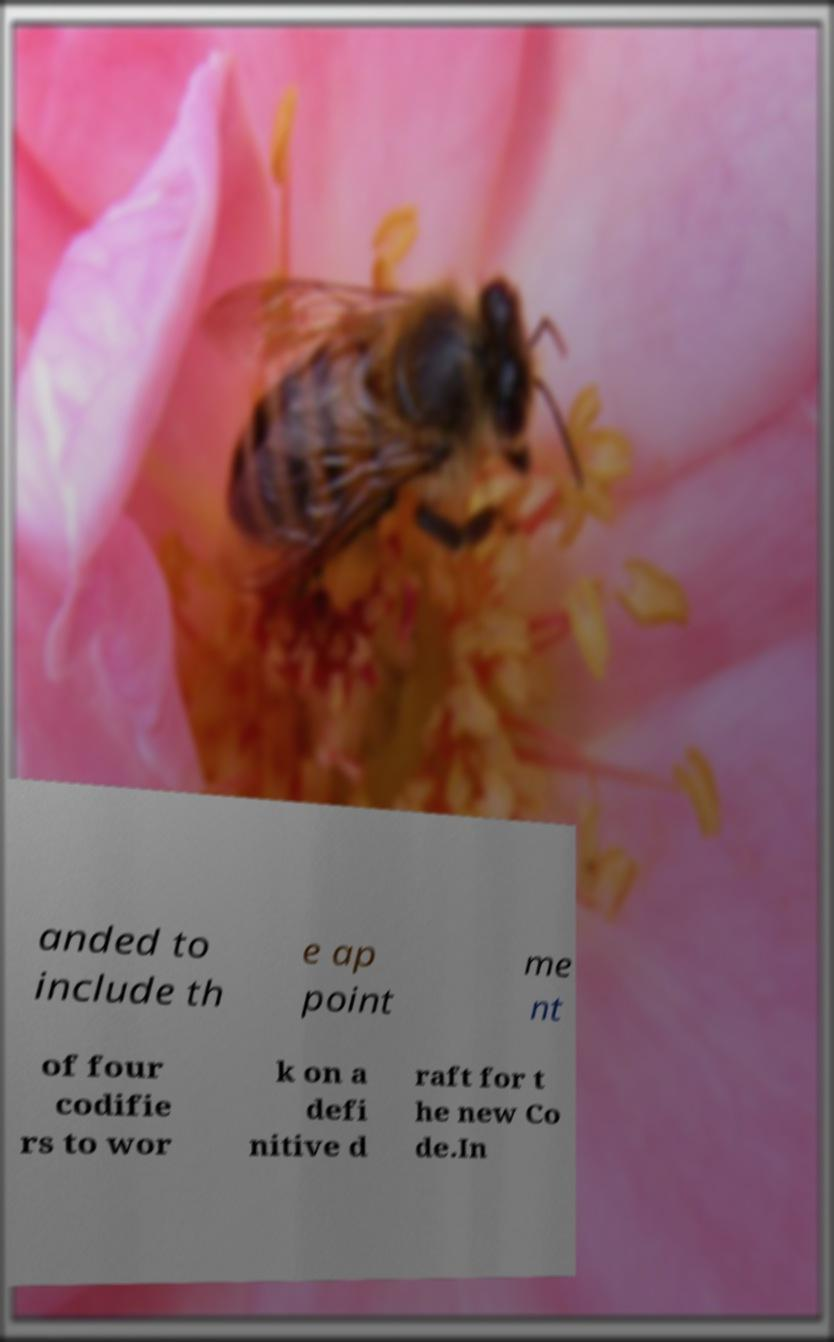I need the written content from this picture converted into text. Can you do that? anded to include th e ap point me nt of four codifie rs to wor k on a defi nitive d raft for t he new Co de.In 